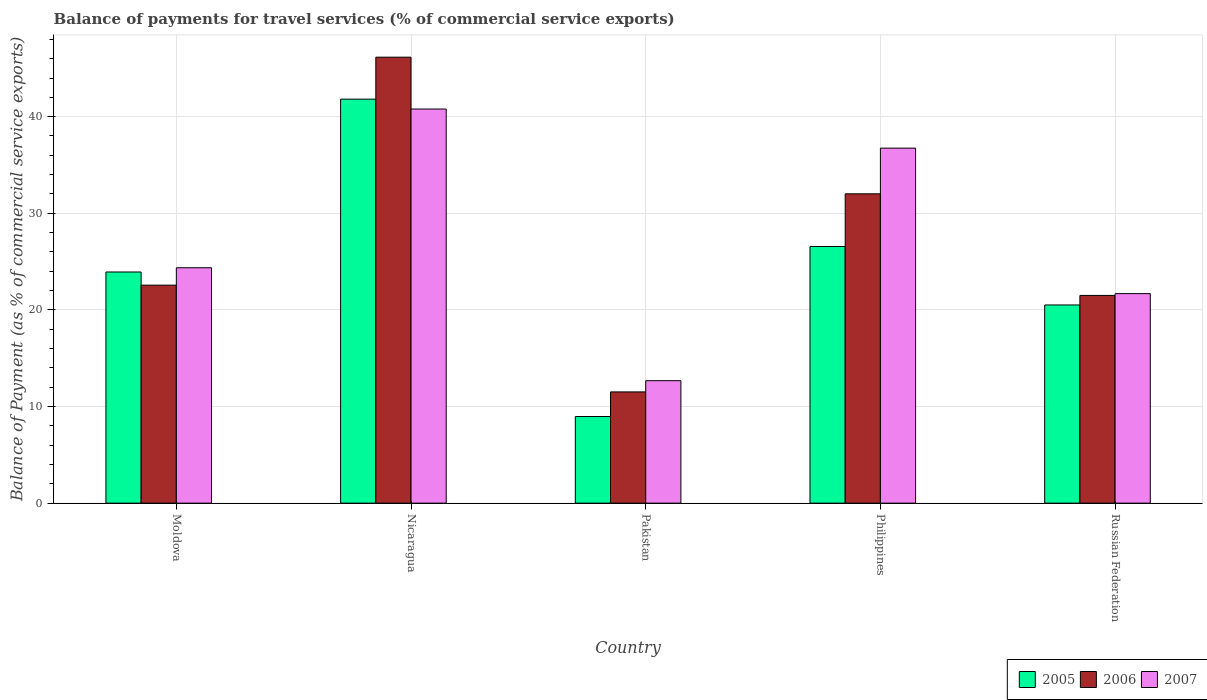How many different coloured bars are there?
Provide a succinct answer. 3. How many groups of bars are there?
Your response must be concise. 5. Are the number of bars on each tick of the X-axis equal?
Provide a succinct answer. Yes. How many bars are there on the 3rd tick from the left?
Make the answer very short. 3. How many bars are there on the 4th tick from the right?
Provide a succinct answer. 3. What is the label of the 5th group of bars from the left?
Offer a very short reply. Russian Federation. In how many cases, is the number of bars for a given country not equal to the number of legend labels?
Your answer should be compact. 0. What is the balance of payments for travel services in 2007 in Philippines?
Offer a terse response. 36.74. Across all countries, what is the maximum balance of payments for travel services in 2007?
Keep it short and to the point. 40.79. Across all countries, what is the minimum balance of payments for travel services in 2006?
Provide a short and direct response. 11.51. In which country was the balance of payments for travel services in 2006 maximum?
Ensure brevity in your answer.  Nicaragua. What is the total balance of payments for travel services in 2007 in the graph?
Provide a short and direct response. 136.26. What is the difference between the balance of payments for travel services in 2007 in Pakistan and that in Philippines?
Provide a short and direct response. -24.07. What is the difference between the balance of payments for travel services in 2007 in Pakistan and the balance of payments for travel services in 2005 in Russian Federation?
Your answer should be compact. -7.84. What is the average balance of payments for travel services in 2006 per country?
Your answer should be compact. 26.75. What is the difference between the balance of payments for travel services of/in 2005 and balance of payments for travel services of/in 2007 in Philippines?
Keep it short and to the point. -10.18. What is the ratio of the balance of payments for travel services in 2006 in Pakistan to that in Philippines?
Provide a succinct answer. 0.36. Is the balance of payments for travel services in 2007 in Moldova less than that in Russian Federation?
Provide a short and direct response. No. What is the difference between the highest and the second highest balance of payments for travel services in 2007?
Provide a short and direct response. 16.43. What is the difference between the highest and the lowest balance of payments for travel services in 2005?
Provide a short and direct response. 32.85. In how many countries, is the balance of payments for travel services in 2007 greater than the average balance of payments for travel services in 2007 taken over all countries?
Give a very brief answer. 2. Is the sum of the balance of payments for travel services in 2005 in Moldova and Pakistan greater than the maximum balance of payments for travel services in 2007 across all countries?
Your answer should be very brief. No. What does the 1st bar from the right in Nicaragua represents?
Offer a terse response. 2007. How many countries are there in the graph?
Your answer should be very brief. 5. What is the difference between two consecutive major ticks on the Y-axis?
Your answer should be compact. 10. Does the graph contain grids?
Your response must be concise. Yes. How are the legend labels stacked?
Your answer should be compact. Horizontal. What is the title of the graph?
Give a very brief answer. Balance of payments for travel services (% of commercial service exports). What is the label or title of the Y-axis?
Ensure brevity in your answer.  Balance of Payment (as % of commercial service exports). What is the Balance of Payment (as % of commercial service exports) in 2005 in Moldova?
Give a very brief answer. 23.92. What is the Balance of Payment (as % of commercial service exports) of 2006 in Moldova?
Provide a short and direct response. 22.56. What is the Balance of Payment (as % of commercial service exports) in 2007 in Moldova?
Offer a terse response. 24.36. What is the Balance of Payment (as % of commercial service exports) of 2005 in Nicaragua?
Your answer should be compact. 41.81. What is the Balance of Payment (as % of commercial service exports) of 2006 in Nicaragua?
Your response must be concise. 46.16. What is the Balance of Payment (as % of commercial service exports) in 2007 in Nicaragua?
Make the answer very short. 40.79. What is the Balance of Payment (as % of commercial service exports) in 2005 in Pakistan?
Provide a succinct answer. 8.97. What is the Balance of Payment (as % of commercial service exports) in 2006 in Pakistan?
Give a very brief answer. 11.51. What is the Balance of Payment (as % of commercial service exports) of 2007 in Pakistan?
Your answer should be compact. 12.67. What is the Balance of Payment (as % of commercial service exports) of 2005 in Philippines?
Keep it short and to the point. 26.56. What is the Balance of Payment (as % of commercial service exports) of 2006 in Philippines?
Provide a succinct answer. 32.02. What is the Balance of Payment (as % of commercial service exports) in 2007 in Philippines?
Keep it short and to the point. 36.74. What is the Balance of Payment (as % of commercial service exports) in 2005 in Russian Federation?
Your answer should be compact. 20.51. What is the Balance of Payment (as % of commercial service exports) in 2006 in Russian Federation?
Provide a short and direct response. 21.5. What is the Balance of Payment (as % of commercial service exports) of 2007 in Russian Federation?
Give a very brief answer. 21.69. Across all countries, what is the maximum Balance of Payment (as % of commercial service exports) in 2005?
Offer a terse response. 41.81. Across all countries, what is the maximum Balance of Payment (as % of commercial service exports) in 2006?
Give a very brief answer. 46.16. Across all countries, what is the maximum Balance of Payment (as % of commercial service exports) of 2007?
Make the answer very short. 40.79. Across all countries, what is the minimum Balance of Payment (as % of commercial service exports) of 2005?
Your answer should be compact. 8.97. Across all countries, what is the minimum Balance of Payment (as % of commercial service exports) in 2006?
Provide a succinct answer. 11.51. Across all countries, what is the minimum Balance of Payment (as % of commercial service exports) of 2007?
Keep it short and to the point. 12.67. What is the total Balance of Payment (as % of commercial service exports) of 2005 in the graph?
Your response must be concise. 121.78. What is the total Balance of Payment (as % of commercial service exports) in 2006 in the graph?
Keep it short and to the point. 133.74. What is the total Balance of Payment (as % of commercial service exports) in 2007 in the graph?
Provide a short and direct response. 136.26. What is the difference between the Balance of Payment (as % of commercial service exports) of 2005 in Moldova and that in Nicaragua?
Keep it short and to the point. -17.89. What is the difference between the Balance of Payment (as % of commercial service exports) in 2006 in Moldova and that in Nicaragua?
Ensure brevity in your answer.  -23.59. What is the difference between the Balance of Payment (as % of commercial service exports) in 2007 in Moldova and that in Nicaragua?
Your answer should be very brief. -16.43. What is the difference between the Balance of Payment (as % of commercial service exports) of 2005 in Moldova and that in Pakistan?
Provide a short and direct response. 14.96. What is the difference between the Balance of Payment (as % of commercial service exports) in 2006 in Moldova and that in Pakistan?
Provide a short and direct response. 11.05. What is the difference between the Balance of Payment (as % of commercial service exports) in 2007 in Moldova and that in Pakistan?
Your answer should be very brief. 11.69. What is the difference between the Balance of Payment (as % of commercial service exports) of 2005 in Moldova and that in Philippines?
Your response must be concise. -2.64. What is the difference between the Balance of Payment (as % of commercial service exports) of 2006 in Moldova and that in Philippines?
Give a very brief answer. -9.45. What is the difference between the Balance of Payment (as % of commercial service exports) in 2007 in Moldova and that in Philippines?
Your answer should be very brief. -12.38. What is the difference between the Balance of Payment (as % of commercial service exports) in 2005 in Moldova and that in Russian Federation?
Provide a succinct answer. 3.41. What is the difference between the Balance of Payment (as % of commercial service exports) of 2006 in Moldova and that in Russian Federation?
Offer a very short reply. 1.06. What is the difference between the Balance of Payment (as % of commercial service exports) of 2007 in Moldova and that in Russian Federation?
Offer a very short reply. 2.68. What is the difference between the Balance of Payment (as % of commercial service exports) in 2005 in Nicaragua and that in Pakistan?
Ensure brevity in your answer.  32.85. What is the difference between the Balance of Payment (as % of commercial service exports) of 2006 in Nicaragua and that in Pakistan?
Provide a short and direct response. 34.64. What is the difference between the Balance of Payment (as % of commercial service exports) of 2007 in Nicaragua and that in Pakistan?
Your answer should be compact. 28.12. What is the difference between the Balance of Payment (as % of commercial service exports) in 2005 in Nicaragua and that in Philippines?
Provide a short and direct response. 15.25. What is the difference between the Balance of Payment (as % of commercial service exports) of 2006 in Nicaragua and that in Philippines?
Keep it short and to the point. 14.14. What is the difference between the Balance of Payment (as % of commercial service exports) of 2007 in Nicaragua and that in Philippines?
Keep it short and to the point. 4.05. What is the difference between the Balance of Payment (as % of commercial service exports) of 2005 in Nicaragua and that in Russian Federation?
Keep it short and to the point. 21.3. What is the difference between the Balance of Payment (as % of commercial service exports) in 2006 in Nicaragua and that in Russian Federation?
Keep it short and to the point. 24.66. What is the difference between the Balance of Payment (as % of commercial service exports) in 2007 in Nicaragua and that in Russian Federation?
Provide a short and direct response. 19.1. What is the difference between the Balance of Payment (as % of commercial service exports) of 2005 in Pakistan and that in Philippines?
Your response must be concise. -17.6. What is the difference between the Balance of Payment (as % of commercial service exports) in 2006 in Pakistan and that in Philippines?
Your response must be concise. -20.5. What is the difference between the Balance of Payment (as % of commercial service exports) of 2007 in Pakistan and that in Philippines?
Ensure brevity in your answer.  -24.07. What is the difference between the Balance of Payment (as % of commercial service exports) of 2005 in Pakistan and that in Russian Federation?
Your response must be concise. -11.55. What is the difference between the Balance of Payment (as % of commercial service exports) of 2006 in Pakistan and that in Russian Federation?
Offer a very short reply. -9.98. What is the difference between the Balance of Payment (as % of commercial service exports) in 2007 in Pakistan and that in Russian Federation?
Your answer should be compact. -9.01. What is the difference between the Balance of Payment (as % of commercial service exports) in 2005 in Philippines and that in Russian Federation?
Ensure brevity in your answer.  6.05. What is the difference between the Balance of Payment (as % of commercial service exports) in 2006 in Philippines and that in Russian Federation?
Your response must be concise. 10.52. What is the difference between the Balance of Payment (as % of commercial service exports) in 2007 in Philippines and that in Russian Federation?
Offer a terse response. 15.06. What is the difference between the Balance of Payment (as % of commercial service exports) in 2005 in Moldova and the Balance of Payment (as % of commercial service exports) in 2006 in Nicaragua?
Give a very brief answer. -22.23. What is the difference between the Balance of Payment (as % of commercial service exports) of 2005 in Moldova and the Balance of Payment (as % of commercial service exports) of 2007 in Nicaragua?
Your answer should be very brief. -16.87. What is the difference between the Balance of Payment (as % of commercial service exports) of 2006 in Moldova and the Balance of Payment (as % of commercial service exports) of 2007 in Nicaragua?
Provide a succinct answer. -18.23. What is the difference between the Balance of Payment (as % of commercial service exports) of 2005 in Moldova and the Balance of Payment (as % of commercial service exports) of 2006 in Pakistan?
Offer a very short reply. 12.41. What is the difference between the Balance of Payment (as % of commercial service exports) of 2005 in Moldova and the Balance of Payment (as % of commercial service exports) of 2007 in Pakistan?
Offer a very short reply. 11.25. What is the difference between the Balance of Payment (as % of commercial service exports) of 2006 in Moldova and the Balance of Payment (as % of commercial service exports) of 2007 in Pakistan?
Provide a succinct answer. 9.89. What is the difference between the Balance of Payment (as % of commercial service exports) in 2005 in Moldova and the Balance of Payment (as % of commercial service exports) in 2006 in Philippines?
Ensure brevity in your answer.  -8.09. What is the difference between the Balance of Payment (as % of commercial service exports) in 2005 in Moldova and the Balance of Payment (as % of commercial service exports) in 2007 in Philippines?
Your response must be concise. -12.82. What is the difference between the Balance of Payment (as % of commercial service exports) of 2006 in Moldova and the Balance of Payment (as % of commercial service exports) of 2007 in Philippines?
Offer a terse response. -14.18. What is the difference between the Balance of Payment (as % of commercial service exports) of 2005 in Moldova and the Balance of Payment (as % of commercial service exports) of 2006 in Russian Federation?
Provide a succinct answer. 2.43. What is the difference between the Balance of Payment (as % of commercial service exports) of 2005 in Moldova and the Balance of Payment (as % of commercial service exports) of 2007 in Russian Federation?
Your answer should be very brief. 2.24. What is the difference between the Balance of Payment (as % of commercial service exports) in 2006 in Moldova and the Balance of Payment (as % of commercial service exports) in 2007 in Russian Federation?
Provide a short and direct response. 0.88. What is the difference between the Balance of Payment (as % of commercial service exports) of 2005 in Nicaragua and the Balance of Payment (as % of commercial service exports) of 2006 in Pakistan?
Make the answer very short. 30.3. What is the difference between the Balance of Payment (as % of commercial service exports) of 2005 in Nicaragua and the Balance of Payment (as % of commercial service exports) of 2007 in Pakistan?
Your answer should be compact. 29.14. What is the difference between the Balance of Payment (as % of commercial service exports) of 2006 in Nicaragua and the Balance of Payment (as % of commercial service exports) of 2007 in Pakistan?
Give a very brief answer. 33.48. What is the difference between the Balance of Payment (as % of commercial service exports) of 2005 in Nicaragua and the Balance of Payment (as % of commercial service exports) of 2006 in Philippines?
Keep it short and to the point. 9.8. What is the difference between the Balance of Payment (as % of commercial service exports) of 2005 in Nicaragua and the Balance of Payment (as % of commercial service exports) of 2007 in Philippines?
Keep it short and to the point. 5.07. What is the difference between the Balance of Payment (as % of commercial service exports) in 2006 in Nicaragua and the Balance of Payment (as % of commercial service exports) in 2007 in Philippines?
Keep it short and to the point. 9.41. What is the difference between the Balance of Payment (as % of commercial service exports) of 2005 in Nicaragua and the Balance of Payment (as % of commercial service exports) of 2006 in Russian Federation?
Keep it short and to the point. 20.31. What is the difference between the Balance of Payment (as % of commercial service exports) of 2005 in Nicaragua and the Balance of Payment (as % of commercial service exports) of 2007 in Russian Federation?
Make the answer very short. 20.13. What is the difference between the Balance of Payment (as % of commercial service exports) of 2006 in Nicaragua and the Balance of Payment (as % of commercial service exports) of 2007 in Russian Federation?
Offer a terse response. 24.47. What is the difference between the Balance of Payment (as % of commercial service exports) of 2005 in Pakistan and the Balance of Payment (as % of commercial service exports) of 2006 in Philippines?
Your answer should be very brief. -23.05. What is the difference between the Balance of Payment (as % of commercial service exports) of 2005 in Pakistan and the Balance of Payment (as % of commercial service exports) of 2007 in Philippines?
Ensure brevity in your answer.  -27.78. What is the difference between the Balance of Payment (as % of commercial service exports) of 2006 in Pakistan and the Balance of Payment (as % of commercial service exports) of 2007 in Philippines?
Make the answer very short. -25.23. What is the difference between the Balance of Payment (as % of commercial service exports) in 2005 in Pakistan and the Balance of Payment (as % of commercial service exports) in 2006 in Russian Federation?
Keep it short and to the point. -12.53. What is the difference between the Balance of Payment (as % of commercial service exports) of 2005 in Pakistan and the Balance of Payment (as % of commercial service exports) of 2007 in Russian Federation?
Ensure brevity in your answer.  -12.72. What is the difference between the Balance of Payment (as % of commercial service exports) of 2006 in Pakistan and the Balance of Payment (as % of commercial service exports) of 2007 in Russian Federation?
Ensure brevity in your answer.  -10.17. What is the difference between the Balance of Payment (as % of commercial service exports) in 2005 in Philippines and the Balance of Payment (as % of commercial service exports) in 2006 in Russian Federation?
Provide a short and direct response. 5.07. What is the difference between the Balance of Payment (as % of commercial service exports) of 2005 in Philippines and the Balance of Payment (as % of commercial service exports) of 2007 in Russian Federation?
Keep it short and to the point. 4.88. What is the difference between the Balance of Payment (as % of commercial service exports) of 2006 in Philippines and the Balance of Payment (as % of commercial service exports) of 2007 in Russian Federation?
Your answer should be very brief. 10.33. What is the average Balance of Payment (as % of commercial service exports) in 2005 per country?
Give a very brief answer. 24.36. What is the average Balance of Payment (as % of commercial service exports) of 2006 per country?
Offer a terse response. 26.75. What is the average Balance of Payment (as % of commercial service exports) in 2007 per country?
Your response must be concise. 27.25. What is the difference between the Balance of Payment (as % of commercial service exports) of 2005 and Balance of Payment (as % of commercial service exports) of 2006 in Moldova?
Offer a very short reply. 1.36. What is the difference between the Balance of Payment (as % of commercial service exports) of 2005 and Balance of Payment (as % of commercial service exports) of 2007 in Moldova?
Offer a very short reply. -0.44. What is the difference between the Balance of Payment (as % of commercial service exports) of 2006 and Balance of Payment (as % of commercial service exports) of 2007 in Moldova?
Your answer should be compact. -1.8. What is the difference between the Balance of Payment (as % of commercial service exports) in 2005 and Balance of Payment (as % of commercial service exports) in 2006 in Nicaragua?
Provide a short and direct response. -4.34. What is the difference between the Balance of Payment (as % of commercial service exports) of 2006 and Balance of Payment (as % of commercial service exports) of 2007 in Nicaragua?
Your response must be concise. 5.37. What is the difference between the Balance of Payment (as % of commercial service exports) in 2005 and Balance of Payment (as % of commercial service exports) in 2006 in Pakistan?
Give a very brief answer. -2.55. What is the difference between the Balance of Payment (as % of commercial service exports) in 2005 and Balance of Payment (as % of commercial service exports) in 2007 in Pakistan?
Offer a terse response. -3.71. What is the difference between the Balance of Payment (as % of commercial service exports) of 2006 and Balance of Payment (as % of commercial service exports) of 2007 in Pakistan?
Your answer should be very brief. -1.16. What is the difference between the Balance of Payment (as % of commercial service exports) in 2005 and Balance of Payment (as % of commercial service exports) in 2006 in Philippines?
Provide a short and direct response. -5.45. What is the difference between the Balance of Payment (as % of commercial service exports) in 2005 and Balance of Payment (as % of commercial service exports) in 2007 in Philippines?
Your answer should be compact. -10.18. What is the difference between the Balance of Payment (as % of commercial service exports) of 2006 and Balance of Payment (as % of commercial service exports) of 2007 in Philippines?
Give a very brief answer. -4.73. What is the difference between the Balance of Payment (as % of commercial service exports) of 2005 and Balance of Payment (as % of commercial service exports) of 2006 in Russian Federation?
Provide a short and direct response. -0.99. What is the difference between the Balance of Payment (as % of commercial service exports) of 2005 and Balance of Payment (as % of commercial service exports) of 2007 in Russian Federation?
Your answer should be compact. -1.17. What is the difference between the Balance of Payment (as % of commercial service exports) of 2006 and Balance of Payment (as % of commercial service exports) of 2007 in Russian Federation?
Provide a succinct answer. -0.19. What is the ratio of the Balance of Payment (as % of commercial service exports) of 2005 in Moldova to that in Nicaragua?
Provide a succinct answer. 0.57. What is the ratio of the Balance of Payment (as % of commercial service exports) in 2006 in Moldova to that in Nicaragua?
Offer a terse response. 0.49. What is the ratio of the Balance of Payment (as % of commercial service exports) in 2007 in Moldova to that in Nicaragua?
Make the answer very short. 0.6. What is the ratio of the Balance of Payment (as % of commercial service exports) of 2005 in Moldova to that in Pakistan?
Give a very brief answer. 2.67. What is the ratio of the Balance of Payment (as % of commercial service exports) in 2006 in Moldova to that in Pakistan?
Your answer should be compact. 1.96. What is the ratio of the Balance of Payment (as % of commercial service exports) of 2007 in Moldova to that in Pakistan?
Provide a short and direct response. 1.92. What is the ratio of the Balance of Payment (as % of commercial service exports) in 2005 in Moldova to that in Philippines?
Your answer should be very brief. 0.9. What is the ratio of the Balance of Payment (as % of commercial service exports) in 2006 in Moldova to that in Philippines?
Your answer should be compact. 0.7. What is the ratio of the Balance of Payment (as % of commercial service exports) of 2007 in Moldova to that in Philippines?
Your response must be concise. 0.66. What is the ratio of the Balance of Payment (as % of commercial service exports) in 2005 in Moldova to that in Russian Federation?
Provide a succinct answer. 1.17. What is the ratio of the Balance of Payment (as % of commercial service exports) of 2006 in Moldova to that in Russian Federation?
Give a very brief answer. 1.05. What is the ratio of the Balance of Payment (as % of commercial service exports) of 2007 in Moldova to that in Russian Federation?
Give a very brief answer. 1.12. What is the ratio of the Balance of Payment (as % of commercial service exports) of 2005 in Nicaragua to that in Pakistan?
Your response must be concise. 4.66. What is the ratio of the Balance of Payment (as % of commercial service exports) in 2006 in Nicaragua to that in Pakistan?
Make the answer very short. 4.01. What is the ratio of the Balance of Payment (as % of commercial service exports) of 2007 in Nicaragua to that in Pakistan?
Ensure brevity in your answer.  3.22. What is the ratio of the Balance of Payment (as % of commercial service exports) of 2005 in Nicaragua to that in Philippines?
Provide a short and direct response. 1.57. What is the ratio of the Balance of Payment (as % of commercial service exports) in 2006 in Nicaragua to that in Philippines?
Offer a terse response. 1.44. What is the ratio of the Balance of Payment (as % of commercial service exports) in 2007 in Nicaragua to that in Philippines?
Offer a very short reply. 1.11. What is the ratio of the Balance of Payment (as % of commercial service exports) of 2005 in Nicaragua to that in Russian Federation?
Ensure brevity in your answer.  2.04. What is the ratio of the Balance of Payment (as % of commercial service exports) in 2006 in Nicaragua to that in Russian Federation?
Ensure brevity in your answer.  2.15. What is the ratio of the Balance of Payment (as % of commercial service exports) of 2007 in Nicaragua to that in Russian Federation?
Provide a short and direct response. 1.88. What is the ratio of the Balance of Payment (as % of commercial service exports) of 2005 in Pakistan to that in Philippines?
Provide a short and direct response. 0.34. What is the ratio of the Balance of Payment (as % of commercial service exports) in 2006 in Pakistan to that in Philippines?
Provide a short and direct response. 0.36. What is the ratio of the Balance of Payment (as % of commercial service exports) of 2007 in Pakistan to that in Philippines?
Provide a short and direct response. 0.34. What is the ratio of the Balance of Payment (as % of commercial service exports) in 2005 in Pakistan to that in Russian Federation?
Give a very brief answer. 0.44. What is the ratio of the Balance of Payment (as % of commercial service exports) of 2006 in Pakistan to that in Russian Federation?
Give a very brief answer. 0.54. What is the ratio of the Balance of Payment (as % of commercial service exports) of 2007 in Pakistan to that in Russian Federation?
Offer a very short reply. 0.58. What is the ratio of the Balance of Payment (as % of commercial service exports) in 2005 in Philippines to that in Russian Federation?
Keep it short and to the point. 1.3. What is the ratio of the Balance of Payment (as % of commercial service exports) in 2006 in Philippines to that in Russian Federation?
Keep it short and to the point. 1.49. What is the ratio of the Balance of Payment (as % of commercial service exports) in 2007 in Philippines to that in Russian Federation?
Your answer should be compact. 1.69. What is the difference between the highest and the second highest Balance of Payment (as % of commercial service exports) of 2005?
Your response must be concise. 15.25. What is the difference between the highest and the second highest Balance of Payment (as % of commercial service exports) in 2006?
Offer a terse response. 14.14. What is the difference between the highest and the second highest Balance of Payment (as % of commercial service exports) of 2007?
Offer a very short reply. 4.05. What is the difference between the highest and the lowest Balance of Payment (as % of commercial service exports) of 2005?
Provide a short and direct response. 32.85. What is the difference between the highest and the lowest Balance of Payment (as % of commercial service exports) in 2006?
Offer a very short reply. 34.64. What is the difference between the highest and the lowest Balance of Payment (as % of commercial service exports) of 2007?
Offer a terse response. 28.12. 